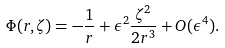<formula> <loc_0><loc_0><loc_500><loc_500>\Phi ( r , \zeta ) = - \frac { 1 } { r } + \epsilon ^ { 2 } \frac { \zeta ^ { 2 } } { 2 r ^ { 3 } } + O ( \epsilon ^ { 4 } ) .</formula> 